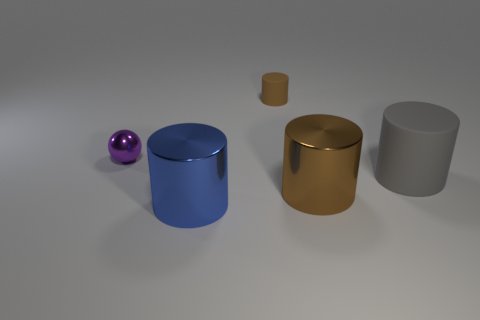Add 2 big metal things. How many objects exist? 7 Subtract all cylinders. How many objects are left? 1 Subtract all blue rubber things. Subtract all small spheres. How many objects are left? 4 Add 1 purple balls. How many purple balls are left? 2 Add 3 cyan cubes. How many cyan cubes exist? 3 Subtract 0 brown balls. How many objects are left? 5 